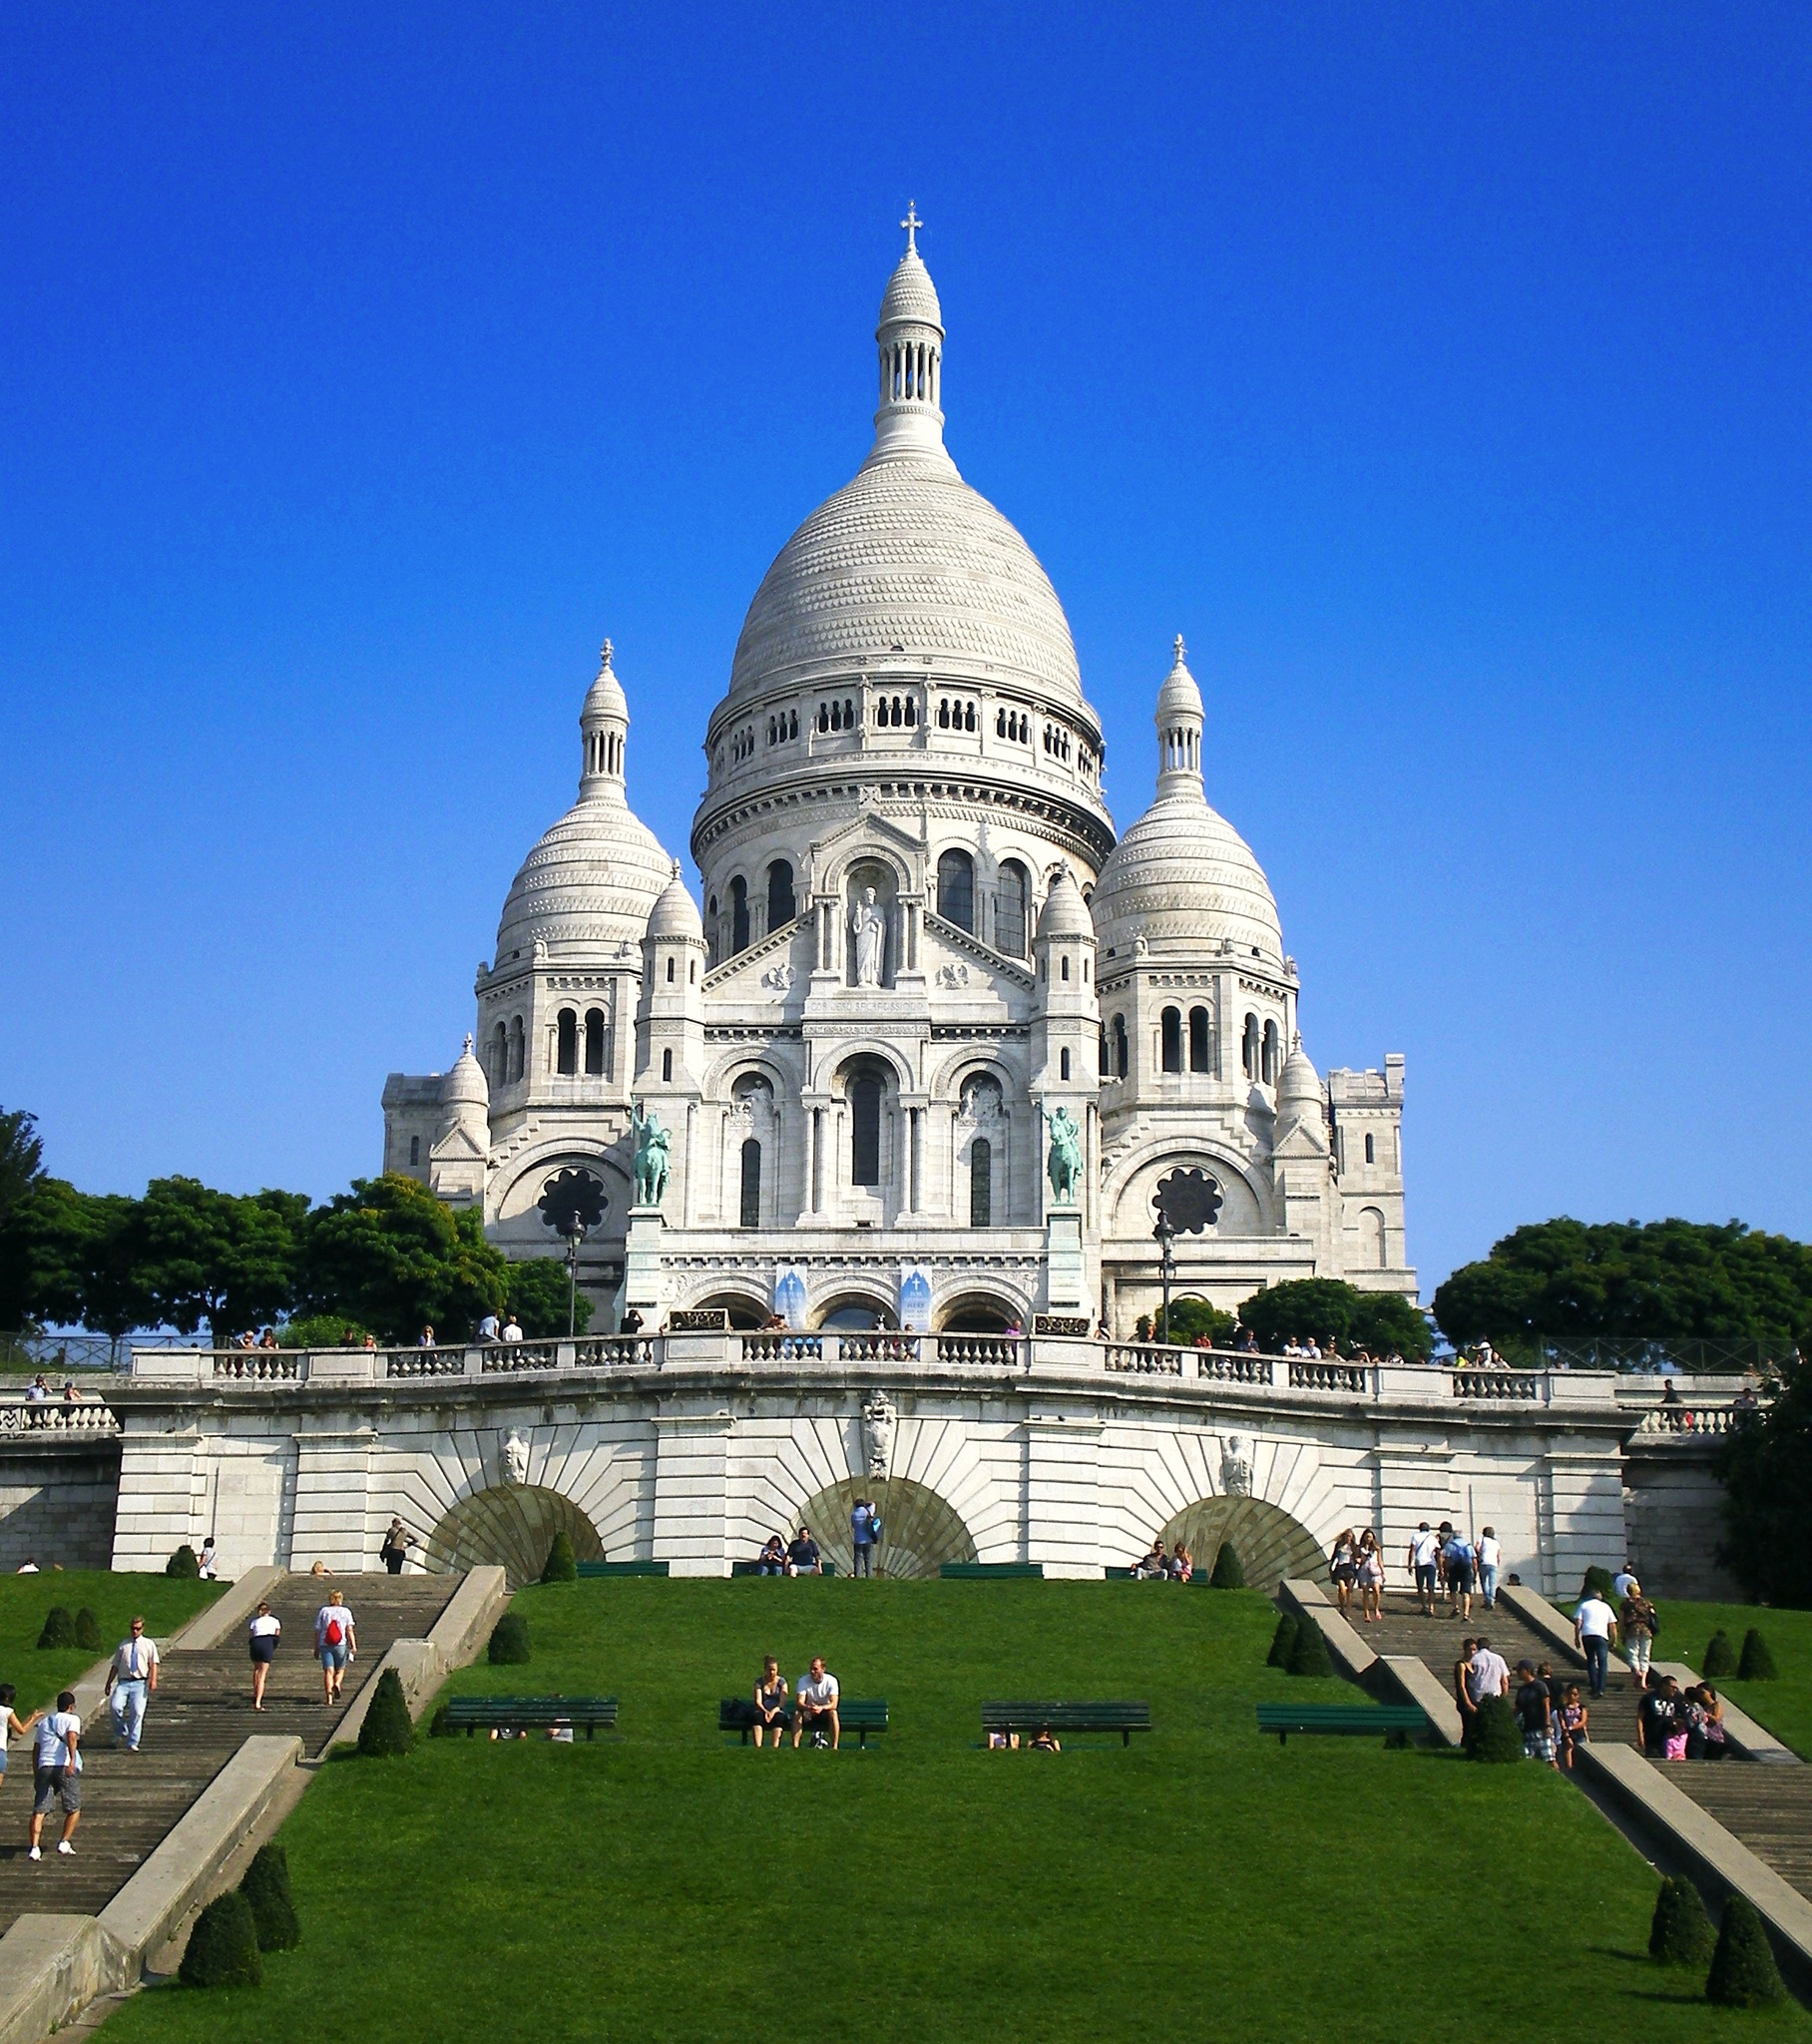Can you describe the main features of this image for me? The image features the stunning Sacr�� Coeur Basilica in Paris, France, prominently displaying its brilliant white travertine stone that glistens under the sun. The basilica stands atop the Montmartre hill, offering not only a spiritual retreat but also a panoramic view of the city from its highest point. Architecturally, the basilica combines Romanesque and Byzantine styles, evident from its domes and arches that add to its grandeur. This historic site is not just a religious symbol but also a cultural hub, often surrounded by locals and tourists who come to enjoy its serene ambiance and the vibrant arts scene typical of Montmartre. 